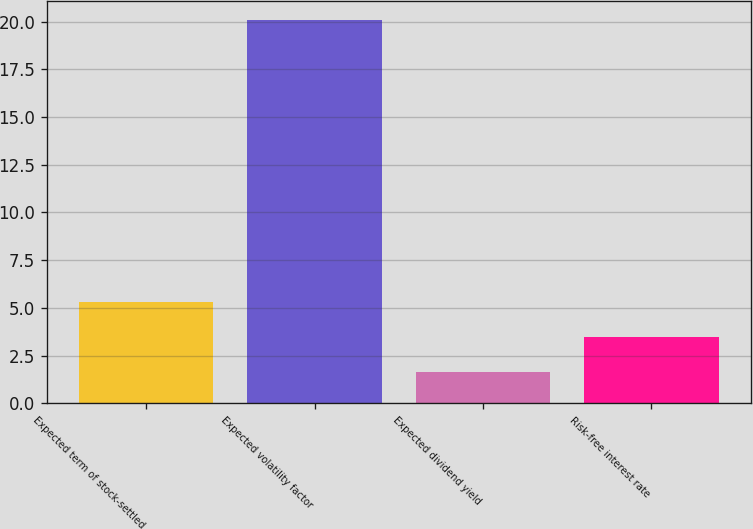<chart> <loc_0><loc_0><loc_500><loc_500><bar_chart><fcel>Expected term of stock-settled<fcel>Expected volatility factor<fcel>Expected dividend yield<fcel>Risk-free interest rate<nl><fcel>5.32<fcel>20.08<fcel>1.63<fcel>3.47<nl></chart> 